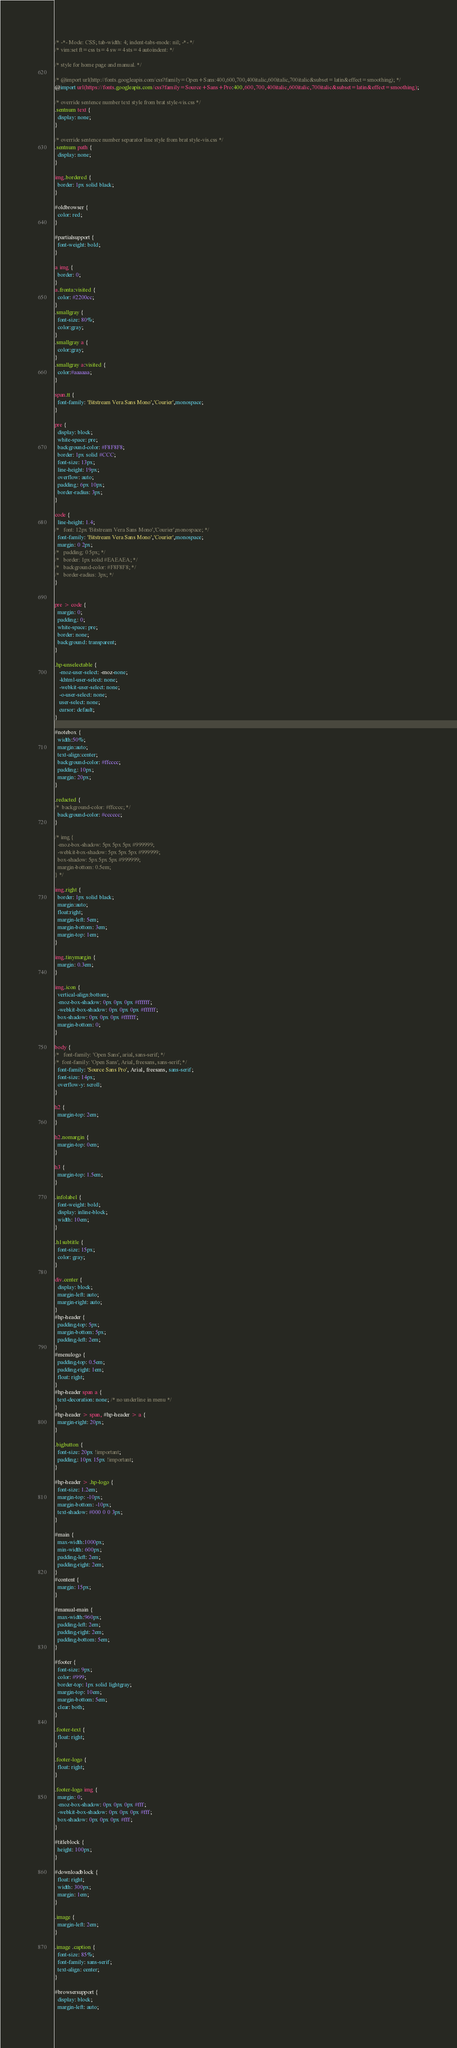<code> <loc_0><loc_0><loc_500><loc_500><_CSS_>/* -*- Mode: CSS; tab-width: 4; indent-tabs-mode: nil; -*- */
/* vim:set ft=css ts=4 sw=4 sts=4 autoindent: */

/* style for home page and manual. */

/* @import url(http://fonts.googleapis.com/css?family=Open+Sans:400,600,700,400italic,600italic,700italic&subset=latin&effect=smoothing); */
@import url(https://fonts.googleapis.com/css?family=Source+Sans+Pro:400,600,700,400italic,600italic,700italic&subset=latin&effect=smoothing);

/* override sentence number text style from brat style-vis.css */
.sentnum text {
  display: none;
}

/* override sentence number separator line style from brat style-vis.css */
.sentnum path {
  display: none;
}

img.bordered {
  border: 1px solid black;
}

#oldbrowser {
  color: red;
}

#partialsupport {
  font-weight: bold;
}

a img {
  border: 0;
}
a.fronta:visited {
  color: #2200cc;
}
.smallgray {
  font-size: 80%;
  color:gray; 
}
.smallgray a {
  color:gray; 
}
.smallgray a:visited {
  color:#aaaaaa; 
}

span.tt {
  font-family: 'Bitstream Vera Sans Mono','Courier',monospace;
}

pre {
  display: block;
  white-space: pre;
  background-color: #F8F8F8;
  border: 1px solid #CCC;
  font-size: 13px;
  line-height: 19px;
  overflow: auto;
  padding: 6px 10px;
  border-radius: 3px;
}

code {
  line-height: 1.4;
/*   font: 12px 'Bitstream Vera Sans Mono','Courier',monospace; */
  font-family: 'Bitstream Vera Sans Mono','Courier',monospace;
  margin: 0 2px;
/*   padding: 0 5px; */
/*   border: 1px solid #EAEAEA; */
/*   background-color: #F8F8F8; */
/*   border-radius: 3px; */
}


pre > code {
  margin: 0;
  padding: 0;
  white-space: pre;
  border: none;
  background: transparent;
}

.hp-unselectable {
   -moz-user-select: -moz-none;
   -khtml-user-select: none;
   -webkit-user-select: none;
   -o-user-select: none;
   user-select: none;
   cursor: default;
}

#notebox {
  width:50%;
  margin:auto;
  text-align:center;
  background-color: #ffcccc;
  padding: 10px;
  margin: 20px;
}

.redacted {
/*  background-color: #ffcccc; */
  background-color: #cccccc;
}

/* img {
  -moz-box-shadow: 5px 5px 5px #999999;
  -webkit-box-shadow: 5px 5px 5px #999999;
  box-shadow: 5px 5px 5px #999999;
  margin-bottom: 0.5em;
} */

img.right {
  border: 1px solid black;
  margin:auto;
  float:right;
  margin-left: 5em;
  margin-bottom: 3em;
  margin-top: 1em;
}

img.tinymargin {
  margin: 0.3em;
}

img.icon {
  vertical-align:bottom;
  -moz-box-shadow: 0px 0px 0px #ffffff;
  -webkit-box-shadow: 0px 0px 0px #ffffff;
  box-shadow: 0px 0px 0px #ffffff;
  margin-bottom: 0;
}

body { 
/*   font-family: 'Open Sans', arial, sans-serif; */
/*  font-family: 'Open Sans', Arial, freesans, sans-serif; */
  font-family: 'Source Sans Pro', Arial, freesans, sans-serif;
  font-size: 14px;
  overflow-y: scroll;
}

h2 {
  margin-top: 2em;
}

h2.nomargin {
  margin-top: 0em;
}

h3 {
  margin-top: 1.5em;
}

.infolabel {
  font-weight: bold;  
  display: inline-block;
  width: 10em;
}

.h1subtitle {
  font-size: 15px;
  color: gray;
}

div.center {
  display: block;
  margin-left: auto;
  margin-right: auto;
}
#hp-header {
  padding-top: 5px;
  margin-bottom: 5px;
  padding-left: 2em;
}
#menulogo {
  padding-top: 0.5em;
  padding-right: 1em;
  float: right;  
}
#hp-header span a {
  text-decoration: none; /* no underline in menu */
}
#hp-header > span, #hp-header > a {
  margin-right: 20px;
}

.bigbutton {
  font-size: 20px !important;
  padding: 10px 15px !important;
}

#hp-header > .hp-logo {
  font-size: 1.2em;
  margin-top: -10px;
  margin-bottom: -10px;
  text-shadow: #000 0 0 3px;
}

#main {
  max-width:1000px;
  min-width: 600px;
  padding-left: 2em;
  padding-right: 2em;
}
#content {
  margin: 15px;
}

#manual-main {
  max-width:960px;
  padding-left: 2em;
  padding-right: 2em;
  padding-bottom: 5em;
}

#footer {
  font-size: 9px;
  color: #999;
  border-top: 1px solid lightgray;
  margin-top: 10em;
  margin-bottom: 5em;
  clear: both;
}

.footer-text {
  float: right;
}

.footer-logo {
  float: right;
}

.footer-logo img {
  margin: 0;
  -moz-box-shadow: 0px 0px 0px #fff;
  -webkit-box-shadow: 0px 0px 0px #fff;
  box-shadow: 0px 0px 0px #fff;
}

#titleblock {
  height: 100px;
}

#downloadblock {
  float: right;
  width: 300px;
  margin: 1em;
}

.image {
  margin-left: 2em;    
}

.image .caption { 
  font-size: 85%;
  font-family: sans-serif;
  text-align: center;
}

#browsersupport {
  display: block;
  margin-left: auto;</code> 